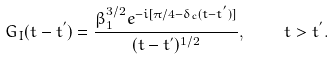<formula> <loc_0><loc_0><loc_500><loc_500>G _ { I } ( t - t ^ { ^ { \prime } } ) = \frac { \beta _ { 1 } ^ { 3 / 2 } e ^ { - i [ \pi / 4 - \delta _ { c } ( t - t ^ { ^ { \prime } } ) ] } } { ( t - t ^ { ^ { \prime } } ) ^ { 1 / 2 } } , \quad \, t > t ^ { ^ { \prime } } .</formula> 